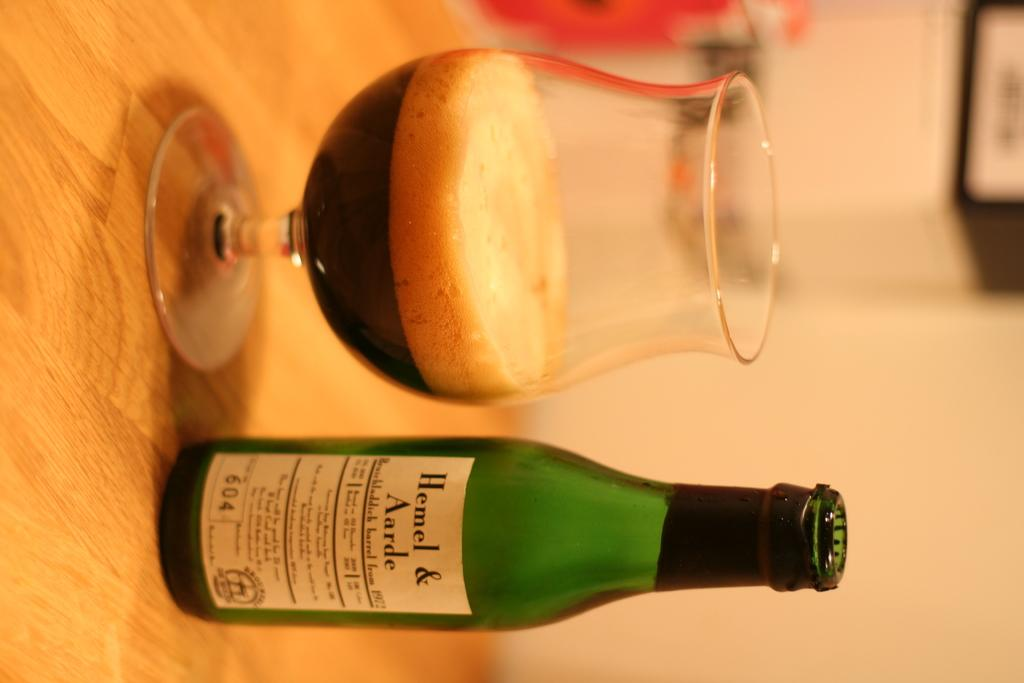What type of bottle is in the image? There is a green color bottle in the image. What is inside the glass in the image? There is a drink in the glass in the image. Where are the bottle and the glass located? Both the bottle and the glass are placed on a table. Can you see any hills or quicksand in the image? No, there are no hills or quicksand present in the image. Are there any sticks visible in the image? No, there are no sticks visible in the image. 